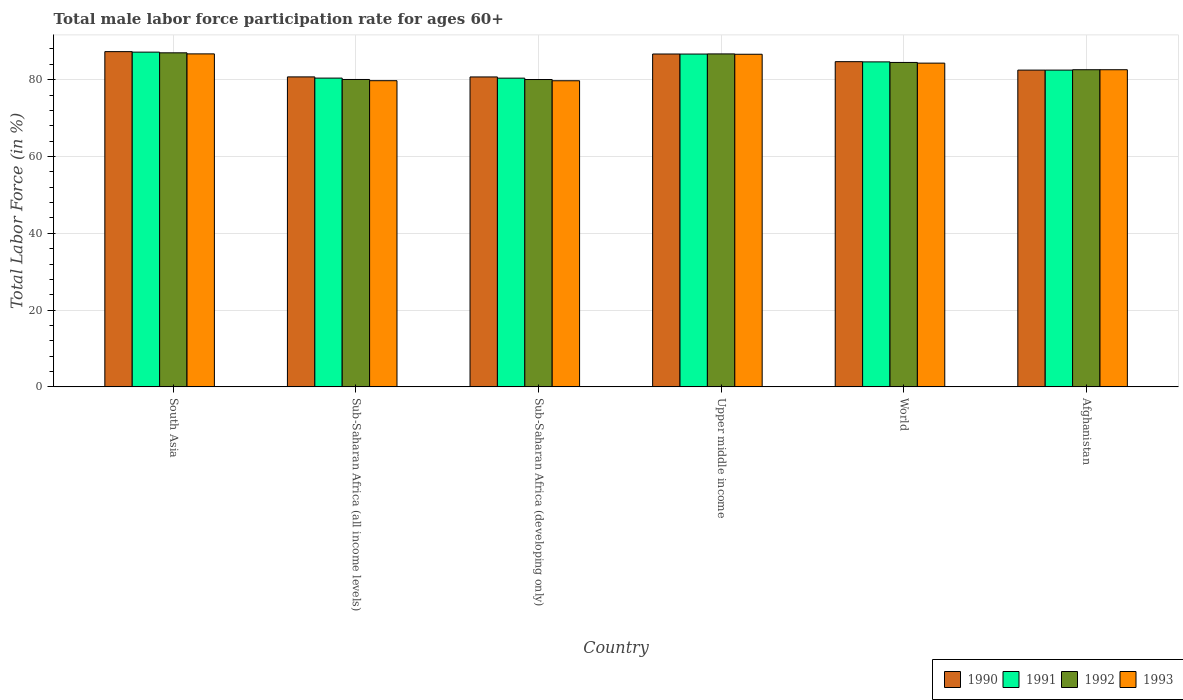How many groups of bars are there?
Your answer should be compact. 6. Are the number of bars per tick equal to the number of legend labels?
Offer a very short reply. Yes. How many bars are there on the 1st tick from the right?
Your answer should be very brief. 4. In how many cases, is the number of bars for a given country not equal to the number of legend labels?
Make the answer very short. 0. What is the male labor force participation rate in 1993 in Upper middle income?
Make the answer very short. 86.63. Across all countries, what is the maximum male labor force participation rate in 1991?
Your response must be concise. 87.18. Across all countries, what is the minimum male labor force participation rate in 1992?
Your answer should be very brief. 80.05. In which country was the male labor force participation rate in 1991 minimum?
Ensure brevity in your answer.  Sub-Saharan Africa (developing only). What is the total male labor force participation rate in 1993 in the graph?
Give a very brief answer. 499.74. What is the difference between the male labor force participation rate in 1993 in Sub-Saharan Africa (all income levels) and that in Upper middle income?
Offer a terse response. -6.89. What is the difference between the male labor force participation rate in 1992 in World and the male labor force participation rate in 1991 in Sub-Saharan Africa (all income levels)?
Keep it short and to the point. 4.08. What is the average male labor force participation rate in 1990 per country?
Your answer should be compact. 83.78. What is the difference between the male labor force participation rate of/in 1991 and male labor force participation rate of/in 1992 in World?
Give a very brief answer. 0.15. In how many countries, is the male labor force participation rate in 1991 greater than 8 %?
Ensure brevity in your answer.  6. What is the ratio of the male labor force participation rate in 1990 in Sub-Saharan Africa (all income levels) to that in Upper middle income?
Provide a succinct answer. 0.93. Is the male labor force participation rate in 1990 in Sub-Saharan Africa (developing only) less than that in Upper middle income?
Offer a terse response. Yes. Is the difference between the male labor force participation rate in 1991 in Upper middle income and World greater than the difference between the male labor force participation rate in 1992 in Upper middle income and World?
Keep it short and to the point. No. What is the difference between the highest and the second highest male labor force participation rate in 1993?
Your answer should be very brief. 2.31. What is the difference between the highest and the lowest male labor force participation rate in 1993?
Keep it short and to the point. 7. Is the sum of the male labor force participation rate in 1993 in Sub-Saharan Africa (all income levels) and Upper middle income greater than the maximum male labor force participation rate in 1990 across all countries?
Make the answer very short. Yes. What does the 2nd bar from the right in Afghanistan represents?
Offer a very short reply. 1992. Does the graph contain grids?
Provide a succinct answer. Yes. Where does the legend appear in the graph?
Provide a short and direct response. Bottom right. How are the legend labels stacked?
Offer a terse response. Horizontal. What is the title of the graph?
Provide a succinct answer. Total male labor force participation rate for ages 60+. What is the label or title of the X-axis?
Provide a succinct answer. Country. What is the label or title of the Y-axis?
Your answer should be very brief. Total Labor Force (in %). What is the Total Labor Force (in %) in 1990 in South Asia?
Provide a succinct answer. 87.31. What is the Total Labor Force (in %) in 1991 in South Asia?
Your answer should be very brief. 87.18. What is the Total Labor Force (in %) of 1992 in South Asia?
Offer a terse response. 87. What is the Total Labor Force (in %) of 1993 in South Asia?
Your response must be concise. 86.73. What is the Total Labor Force (in %) of 1990 in Sub-Saharan Africa (all income levels)?
Ensure brevity in your answer.  80.73. What is the Total Labor Force (in %) in 1991 in Sub-Saharan Africa (all income levels)?
Keep it short and to the point. 80.42. What is the Total Labor Force (in %) of 1992 in Sub-Saharan Africa (all income levels)?
Offer a terse response. 80.06. What is the Total Labor Force (in %) of 1993 in Sub-Saharan Africa (all income levels)?
Keep it short and to the point. 79.74. What is the Total Labor Force (in %) of 1990 in Sub-Saharan Africa (developing only)?
Ensure brevity in your answer.  80.72. What is the Total Labor Force (in %) of 1991 in Sub-Saharan Africa (developing only)?
Give a very brief answer. 80.41. What is the Total Labor Force (in %) of 1992 in Sub-Saharan Africa (developing only)?
Your answer should be compact. 80.05. What is the Total Labor Force (in %) in 1993 in Sub-Saharan Africa (developing only)?
Keep it short and to the point. 79.73. What is the Total Labor Force (in %) in 1990 in Upper middle income?
Provide a short and direct response. 86.69. What is the Total Labor Force (in %) in 1991 in Upper middle income?
Give a very brief answer. 86.68. What is the Total Labor Force (in %) in 1992 in Upper middle income?
Keep it short and to the point. 86.72. What is the Total Labor Force (in %) of 1993 in Upper middle income?
Your answer should be very brief. 86.63. What is the Total Labor Force (in %) of 1990 in World?
Your answer should be compact. 84.7. What is the Total Labor Force (in %) of 1991 in World?
Your answer should be very brief. 84.64. What is the Total Labor Force (in %) in 1992 in World?
Make the answer very short. 84.49. What is the Total Labor Force (in %) of 1993 in World?
Offer a terse response. 84.32. What is the Total Labor Force (in %) in 1990 in Afghanistan?
Keep it short and to the point. 82.5. What is the Total Labor Force (in %) in 1991 in Afghanistan?
Your response must be concise. 82.5. What is the Total Labor Force (in %) in 1992 in Afghanistan?
Your response must be concise. 82.6. What is the Total Labor Force (in %) in 1993 in Afghanistan?
Ensure brevity in your answer.  82.6. Across all countries, what is the maximum Total Labor Force (in %) in 1990?
Give a very brief answer. 87.31. Across all countries, what is the maximum Total Labor Force (in %) of 1991?
Your response must be concise. 87.18. Across all countries, what is the maximum Total Labor Force (in %) in 1992?
Make the answer very short. 87. Across all countries, what is the maximum Total Labor Force (in %) of 1993?
Offer a very short reply. 86.73. Across all countries, what is the minimum Total Labor Force (in %) in 1990?
Keep it short and to the point. 80.72. Across all countries, what is the minimum Total Labor Force (in %) in 1991?
Your response must be concise. 80.41. Across all countries, what is the minimum Total Labor Force (in %) of 1992?
Provide a short and direct response. 80.05. Across all countries, what is the minimum Total Labor Force (in %) in 1993?
Keep it short and to the point. 79.73. What is the total Total Labor Force (in %) of 1990 in the graph?
Your answer should be very brief. 502.65. What is the total Total Labor Force (in %) in 1991 in the graph?
Provide a succinct answer. 501.83. What is the total Total Labor Force (in %) in 1992 in the graph?
Your response must be concise. 500.92. What is the total Total Labor Force (in %) in 1993 in the graph?
Offer a terse response. 499.74. What is the difference between the Total Labor Force (in %) of 1990 in South Asia and that in Sub-Saharan Africa (all income levels)?
Your answer should be very brief. 6.58. What is the difference between the Total Labor Force (in %) in 1991 in South Asia and that in Sub-Saharan Africa (all income levels)?
Your answer should be compact. 6.76. What is the difference between the Total Labor Force (in %) in 1992 in South Asia and that in Sub-Saharan Africa (all income levels)?
Keep it short and to the point. 6.94. What is the difference between the Total Labor Force (in %) in 1993 in South Asia and that in Sub-Saharan Africa (all income levels)?
Ensure brevity in your answer.  6.99. What is the difference between the Total Labor Force (in %) in 1990 in South Asia and that in Sub-Saharan Africa (developing only)?
Ensure brevity in your answer.  6.59. What is the difference between the Total Labor Force (in %) of 1991 in South Asia and that in Sub-Saharan Africa (developing only)?
Give a very brief answer. 6.77. What is the difference between the Total Labor Force (in %) of 1992 in South Asia and that in Sub-Saharan Africa (developing only)?
Your answer should be very brief. 6.95. What is the difference between the Total Labor Force (in %) of 1993 in South Asia and that in Sub-Saharan Africa (developing only)?
Keep it short and to the point. 7. What is the difference between the Total Labor Force (in %) of 1990 in South Asia and that in Upper middle income?
Give a very brief answer. 0.62. What is the difference between the Total Labor Force (in %) of 1991 in South Asia and that in Upper middle income?
Offer a terse response. 0.5. What is the difference between the Total Labor Force (in %) in 1992 in South Asia and that in Upper middle income?
Make the answer very short. 0.28. What is the difference between the Total Labor Force (in %) of 1993 in South Asia and that in Upper middle income?
Provide a succinct answer. 0.1. What is the difference between the Total Labor Force (in %) in 1990 in South Asia and that in World?
Your answer should be very brief. 2.61. What is the difference between the Total Labor Force (in %) of 1991 in South Asia and that in World?
Provide a succinct answer. 2.54. What is the difference between the Total Labor Force (in %) of 1992 in South Asia and that in World?
Your answer should be compact. 2.51. What is the difference between the Total Labor Force (in %) of 1993 in South Asia and that in World?
Make the answer very short. 2.41. What is the difference between the Total Labor Force (in %) of 1990 in South Asia and that in Afghanistan?
Keep it short and to the point. 4.81. What is the difference between the Total Labor Force (in %) in 1991 in South Asia and that in Afghanistan?
Your answer should be compact. 4.68. What is the difference between the Total Labor Force (in %) in 1992 in South Asia and that in Afghanistan?
Make the answer very short. 4.4. What is the difference between the Total Labor Force (in %) in 1993 in South Asia and that in Afghanistan?
Your response must be concise. 4.13. What is the difference between the Total Labor Force (in %) of 1990 in Sub-Saharan Africa (all income levels) and that in Sub-Saharan Africa (developing only)?
Provide a succinct answer. 0.01. What is the difference between the Total Labor Force (in %) of 1991 in Sub-Saharan Africa (all income levels) and that in Sub-Saharan Africa (developing only)?
Your response must be concise. 0.01. What is the difference between the Total Labor Force (in %) of 1992 in Sub-Saharan Africa (all income levels) and that in Sub-Saharan Africa (developing only)?
Your response must be concise. 0.01. What is the difference between the Total Labor Force (in %) in 1993 in Sub-Saharan Africa (all income levels) and that in Sub-Saharan Africa (developing only)?
Make the answer very short. 0.01. What is the difference between the Total Labor Force (in %) in 1990 in Sub-Saharan Africa (all income levels) and that in Upper middle income?
Your response must be concise. -5.96. What is the difference between the Total Labor Force (in %) in 1991 in Sub-Saharan Africa (all income levels) and that in Upper middle income?
Give a very brief answer. -6.26. What is the difference between the Total Labor Force (in %) in 1992 in Sub-Saharan Africa (all income levels) and that in Upper middle income?
Give a very brief answer. -6.66. What is the difference between the Total Labor Force (in %) of 1993 in Sub-Saharan Africa (all income levels) and that in Upper middle income?
Ensure brevity in your answer.  -6.89. What is the difference between the Total Labor Force (in %) in 1990 in Sub-Saharan Africa (all income levels) and that in World?
Provide a succinct answer. -3.97. What is the difference between the Total Labor Force (in %) of 1991 in Sub-Saharan Africa (all income levels) and that in World?
Provide a succinct answer. -4.22. What is the difference between the Total Labor Force (in %) in 1992 in Sub-Saharan Africa (all income levels) and that in World?
Your answer should be compact. -4.43. What is the difference between the Total Labor Force (in %) of 1993 in Sub-Saharan Africa (all income levels) and that in World?
Offer a terse response. -4.57. What is the difference between the Total Labor Force (in %) in 1990 in Sub-Saharan Africa (all income levels) and that in Afghanistan?
Give a very brief answer. -1.77. What is the difference between the Total Labor Force (in %) of 1991 in Sub-Saharan Africa (all income levels) and that in Afghanistan?
Offer a terse response. -2.08. What is the difference between the Total Labor Force (in %) in 1992 in Sub-Saharan Africa (all income levels) and that in Afghanistan?
Your answer should be compact. -2.54. What is the difference between the Total Labor Force (in %) in 1993 in Sub-Saharan Africa (all income levels) and that in Afghanistan?
Provide a short and direct response. -2.86. What is the difference between the Total Labor Force (in %) in 1990 in Sub-Saharan Africa (developing only) and that in Upper middle income?
Ensure brevity in your answer.  -5.97. What is the difference between the Total Labor Force (in %) in 1991 in Sub-Saharan Africa (developing only) and that in Upper middle income?
Your response must be concise. -6.27. What is the difference between the Total Labor Force (in %) of 1992 in Sub-Saharan Africa (developing only) and that in Upper middle income?
Your answer should be very brief. -6.67. What is the difference between the Total Labor Force (in %) of 1990 in Sub-Saharan Africa (developing only) and that in World?
Offer a very short reply. -3.98. What is the difference between the Total Labor Force (in %) in 1991 in Sub-Saharan Africa (developing only) and that in World?
Make the answer very short. -4.24. What is the difference between the Total Labor Force (in %) in 1992 in Sub-Saharan Africa (developing only) and that in World?
Make the answer very short. -4.45. What is the difference between the Total Labor Force (in %) in 1993 in Sub-Saharan Africa (developing only) and that in World?
Offer a terse response. -4.59. What is the difference between the Total Labor Force (in %) in 1990 in Sub-Saharan Africa (developing only) and that in Afghanistan?
Offer a very short reply. -1.78. What is the difference between the Total Labor Force (in %) of 1991 in Sub-Saharan Africa (developing only) and that in Afghanistan?
Provide a short and direct response. -2.09. What is the difference between the Total Labor Force (in %) of 1992 in Sub-Saharan Africa (developing only) and that in Afghanistan?
Provide a succinct answer. -2.55. What is the difference between the Total Labor Force (in %) in 1993 in Sub-Saharan Africa (developing only) and that in Afghanistan?
Your response must be concise. -2.87. What is the difference between the Total Labor Force (in %) in 1990 in Upper middle income and that in World?
Ensure brevity in your answer.  1.99. What is the difference between the Total Labor Force (in %) of 1991 in Upper middle income and that in World?
Your answer should be very brief. 2.04. What is the difference between the Total Labor Force (in %) of 1992 in Upper middle income and that in World?
Offer a very short reply. 2.22. What is the difference between the Total Labor Force (in %) of 1993 in Upper middle income and that in World?
Offer a terse response. 2.31. What is the difference between the Total Labor Force (in %) of 1990 in Upper middle income and that in Afghanistan?
Keep it short and to the point. 4.19. What is the difference between the Total Labor Force (in %) in 1991 in Upper middle income and that in Afghanistan?
Offer a very short reply. 4.18. What is the difference between the Total Labor Force (in %) in 1992 in Upper middle income and that in Afghanistan?
Offer a very short reply. 4.12. What is the difference between the Total Labor Force (in %) in 1993 in Upper middle income and that in Afghanistan?
Offer a very short reply. 4.03. What is the difference between the Total Labor Force (in %) of 1990 in World and that in Afghanistan?
Provide a succinct answer. 2.2. What is the difference between the Total Labor Force (in %) in 1991 in World and that in Afghanistan?
Your answer should be compact. 2.14. What is the difference between the Total Labor Force (in %) of 1992 in World and that in Afghanistan?
Make the answer very short. 1.89. What is the difference between the Total Labor Force (in %) in 1993 in World and that in Afghanistan?
Your answer should be very brief. 1.72. What is the difference between the Total Labor Force (in %) in 1990 in South Asia and the Total Labor Force (in %) in 1991 in Sub-Saharan Africa (all income levels)?
Keep it short and to the point. 6.89. What is the difference between the Total Labor Force (in %) in 1990 in South Asia and the Total Labor Force (in %) in 1992 in Sub-Saharan Africa (all income levels)?
Your answer should be compact. 7.25. What is the difference between the Total Labor Force (in %) of 1990 in South Asia and the Total Labor Force (in %) of 1993 in Sub-Saharan Africa (all income levels)?
Make the answer very short. 7.57. What is the difference between the Total Labor Force (in %) in 1991 in South Asia and the Total Labor Force (in %) in 1992 in Sub-Saharan Africa (all income levels)?
Keep it short and to the point. 7.12. What is the difference between the Total Labor Force (in %) in 1991 in South Asia and the Total Labor Force (in %) in 1993 in Sub-Saharan Africa (all income levels)?
Provide a succinct answer. 7.44. What is the difference between the Total Labor Force (in %) in 1992 in South Asia and the Total Labor Force (in %) in 1993 in Sub-Saharan Africa (all income levels)?
Ensure brevity in your answer.  7.26. What is the difference between the Total Labor Force (in %) of 1990 in South Asia and the Total Labor Force (in %) of 1991 in Sub-Saharan Africa (developing only)?
Give a very brief answer. 6.9. What is the difference between the Total Labor Force (in %) in 1990 in South Asia and the Total Labor Force (in %) in 1992 in Sub-Saharan Africa (developing only)?
Ensure brevity in your answer.  7.26. What is the difference between the Total Labor Force (in %) in 1990 in South Asia and the Total Labor Force (in %) in 1993 in Sub-Saharan Africa (developing only)?
Provide a short and direct response. 7.58. What is the difference between the Total Labor Force (in %) in 1991 in South Asia and the Total Labor Force (in %) in 1992 in Sub-Saharan Africa (developing only)?
Provide a succinct answer. 7.13. What is the difference between the Total Labor Force (in %) in 1991 in South Asia and the Total Labor Force (in %) in 1993 in Sub-Saharan Africa (developing only)?
Make the answer very short. 7.45. What is the difference between the Total Labor Force (in %) in 1992 in South Asia and the Total Labor Force (in %) in 1993 in Sub-Saharan Africa (developing only)?
Your answer should be compact. 7.27. What is the difference between the Total Labor Force (in %) of 1990 in South Asia and the Total Labor Force (in %) of 1991 in Upper middle income?
Your answer should be very brief. 0.63. What is the difference between the Total Labor Force (in %) of 1990 in South Asia and the Total Labor Force (in %) of 1992 in Upper middle income?
Offer a terse response. 0.59. What is the difference between the Total Labor Force (in %) of 1990 in South Asia and the Total Labor Force (in %) of 1993 in Upper middle income?
Provide a short and direct response. 0.68. What is the difference between the Total Labor Force (in %) of 1991 in South Asia and the Total Labor Force (in %) of 1992 in Upper middle income?
Your response must be concise. 0.46. What is the difference between the Total Labor Force (in %) in 1991 in South Asia and the Total Labor Force (in %) in 1993 in Upper middle income?
Offer a very short reply. 0.55. What is the difference between the Total Labor Force (in %) in 1992 in South Asia and the Total Labor Force (in %) in 1993 in Upper middle income?
Provide a succinct answer. 0.37. What is the difference between the Total Labor Force (in %) of 1990 in South Asia and the Total Labor Force (in %) of 1991 in World?
Make the answer very short. 2.67. What is the difference between the Total Labor Force (in %) of 1990 in South Asia and the Total Labor Force (in %) of 1992 in World?
Your response must be concise. 2.82. What is the difference between the Total Labor Force (in %) in 1990 in South Asia and the Total Labor Force (in %) in 1993 in World?
Your answer should be compact. 3. What is the difference between the Total Labor Force (in %) in 1991 in South Asia and the Total Labor Force (in %) in 1992 in World?
Provide a short and direct response. 2.69. What is the difference between the Total Labor Force (in %) in 1991 in South Asia and the Total Labor Force (in %) in 1993 in World?
Keep it short and to the point. 2.87. What is the difference between the Total Labor Force (in %) of 1992 in South Asia and the Total Labor Force (in %) of 1993 in World?
Ensure brevity in your answer.  2.69. What is the difference between the Total Labor Force (in %) in 1990 in South Asia and the Total Labor Force (in %) in 1991 in Afghanistan?
Offer a very short reply. 4.81. What is the difference between the Total Labor Force (in %) in 1990 in South Asia and the Total Labor Force (in %) in 1992 in Afghanistan?
Provide a succinct answer. 4.71. What is the difference between the Total Labor Force (in %) in 1990 in South Asia and the Total Labor Force (in %) in 1993 in Afghanistan?
Give a very brief answer. 4.71. What is the difference between the Total Labor Force (in %) in 1991 in South Asia and the Total Labor Force (in %) in 1992 in Afghanistan?
Make the answer very short. 4.58. What is the difference between the Total Labor Force (in %) of 1991 in South Asia and the Total Labor Force (in %) of 1993 in Afghanistan?
Your response must be concise. 4.58. What is the difference between the Total Labor Force (in %) of 1992 in South Asia and the Total Labor Force (in %) of 1993 in Afghanistan?
Ensure brevity in your answer.  4.4. What is the difference between the Total Labor Force (in %) of 1990 in Sub-Saharan Africa (all income levels) and the Total Labor Force (in %) of 1991 in Sub-Saharan Africa (developing only)?
Provide a succinct answer. 0.33. What is the difference between the Total Labor Force (in %) in 1990 in Sub-Saharan Africa (all income levels) and the Total Labor Force (in %) in 1992 in Sub-Saharan Africa (developing only)?
Your answer should be very brief. 0.68. What is the difference between the Total Labor Force (in %) of 1991 in Sub-Saharan Africa (all income levels) and the Total Labor Force (in %) of 1992 in Sub-Saharan Africa (developing only)?
Offer a terse response. 0.37. What is the difference between the Total Labor Force (in %) in 1991 in Sub-Saharan Africa (all income levels) and the Total Labor Force (in %) in 1993 in Sub-Saharan Africa (developing only)?
Offer a terse response. 0.69. What is the difference between the Total Labor Force (in %) of 1992 in Sub-Saharan Africa (all income levels) and the Total Labor Force (in %) of 1993 in Sub-Saharan Africa (developing only)?
Your answer should be very brief. 0.33. What is the difference between the Total Labor Force (in %) in 1990 in Sub-Saharan Africa (all income levels) and the Total Labor Force (in %) in 1991 in Upper middle income?
Provide a short and direct response. -5.95. What is the difference between the Total Labor Force (in %) of 1990 in Sub-Saharan Africa (all income levels) and the Total Labor Force (in %) of 1992 in Upper middle income?
Provide a short and direct response. -5.99. What is the difference between the Total Labor Force (in %) in 1990 in Sub-Saharan Africa (all income levels) and the Total Labor Force (in %) in 1993 in Upper middle income?
Provide a short and direct response. -5.9. What is the difference between the Total Labor Force (in %) of 1991 in Sub-Saharan Africa (all income levels) and the Total Labor Force (in %) of 1992 in Upper middle income?
Keep it short and to the point. -6.3. What is the difference between the Total Labor Force (in %) in 1991 in Sub-Saharan Africa (all income levels) and the Total Labor Force (in %) in 1993 in Upper middle income?
Your response must be concise. -6.21. What is the difference between the Total Labor Force (in %) of 1992 in Sub-Saharan Africa (all income levels) and the Total Labor Force (in %) of 1993 in Upper middle income?
Your answer should be compact. -6.57. What is the difference between the Total Labor Force (in %) of 1990 in Sub-Saharan Africa (all income levels) and the Total Labor Force (in %) of 1991 in World?
Offer a terse response. -3.91. What is the difference between the Total Labor Force (in %) in 1990 in Sub-Saharan Africa (all income levels) and the Total Labor Force (in %) in 1992 in World?
Provide a succinct answer. -3.76. What is the difference between the Total Labor Force (in %) of 1990 in Sub-Saharan Africa (all income levels) and the Total Labor Force (in %) of 1993 in World?
Keep it short and to the point. -3.58. What is the difference between the Total Labor Force (in %) of 1991 in Sub-Saharan Africa (all income levels) and the Total Labor Force (in %) of 1992 in World?
Offer a very short reply. -4.08. What is the difference between the Total Labor Force (in %) in 1991 in Sub-Saharan Africa (all income levels) and the Total Labor Force (in %) in 1993 in World?
Ensure brevity in your answer.  -3.9. What is the difference between the Total Labor Force (in %) of 1992 in Sub-Saharan Africa (all income levels) and the Total Labor Force (in %) of 1993 in World?
Keep it short and to the point. -4.25. What is the difference between the Total Labor Force (in %) of 1990 in Sub-Saharan Africa (all income levels) and the Total Labor Force (in %) of 1991 in Afghanistan?
Your answer should be very brief. -1.77. What is the difference between the Total Labor Force (in %) of 1990 in Sub-Saharan Africa (all income levels) and the Total Labor Force (in %) of 1992 in Afghanistan?
Your response must be concise. -1.87. What is the difference between the Total Labor Force (in %) in 1990 in Sub-Saharan Africa (all income levels) and the Total Labor Force (in %) in 1993 in Afghanistan?
Your answer should be compact. -1.87. What is the difference between the Total Labor Force (in %) of 1991 in Sub-Saharan Africa (all income levels) and the Total Labor Force (in %) of 1992 in Afghanistan?
Your response must be concise. -2.18. What is the difference between the Total Labor Force (in %) in 1991 in Sub-Saharan Africa (all income levels) and the Total Labor Force (in %) in 1993 in Afghanistan?
Offer a very short reply. -2.18. What is the difference between the Total Labor Force (in %) of 1992 in Sub-Saharan Africa (all income levels) and the Total Labor Force (in %) of 1993 in Afghanistan?
Keep it short and to the point. -2.54. What is the difference between the Total Labor Force (in %) of 1990 in Sub-Saharan Africa (developing only) and the Total Labor Force (in %) of 1991 in Upper middle income?
Your response must be concise. -5.96. What is the difference between the Total Labor Force (in %) of 1990 in Sub-Saharan Africa (developing only) and the Total Labor Force (in %) of 1992 in Upper middle income?
Provide a short and direct response. -6. What is the difference between the Total Labor Force (in %) in 1990 in Sub-Saharan Africa (developing only) and the Total Labor Force (in %) in 1993 in Upper middle income?
Your answer should be very brief. -5.91. What is the difference between the Total Labor Force (in %) in 1991 in Sub-Saharan Africa (developing only) and the Total Labor Force (in %) in 1992 in Upper middle income?
Give a very brief answer. -6.31. What is the difference between the Total Labor Force (in %) in 1991 in Sub-Saharan Africa (developing only) and the Total Labor Force (in %) in 1993 in Upper middle income?
Give a very brief answer. -6.22. What is the difference between the Total Labor Force (in %) of 1992 in Sub-Saharan Africa (developing only) and the Total Labor Force (in %) of 1993 in Upper middle income?
Keep it short and to the point. -6.58. What is the difference between the Total Labor Force (in %) in 1990 in Sub-Saharan Africa (developing only) and the Total Labor Force (in %) in 1991 in World?
Make the answer very short. -3.92. What is the difference between the Total Labor Force (in %) of 1990 in Sub-Saharan Africa (developing only) and the Total Labor Force (in %) of 1992 in World?
Offer a terse response. -3.77. What is the difference between the Total Labor Force (in %) of 1990 in Sub-Saharan Africa (developing only) and the Total Labor Force (in %) of 1993 in World?
Your answer should be very brief. -3.59. What is the difference between the Total Labor Force (in %) of 1991 in Sub-Saharan Africa (developing only) and the Total Labor Force (in %) of 1992 in World?
Ensure brevity in your answer.  -4.09. What is the difference between the Total Labor Force (in %) of 1991 in Sub-Saharan Africa (developing only) and the Total Labor Force (in %) of 1993 in World?
Your answer should be compact. -3.91. What is the difference between the Total Labor Force (in %) in 1992 in Sub-Saharan Africa (developing only) and the Total Labor Force (in %) in 1993 in World?
Give a very brief answer. -4.27. What is the difference between the Total Labor Force (in %) of 1990 in Sub-Saharan Africa (developing only) and the Total Labor Force (in %) of 1991 in Afghanistan?
Offer a very short reply. -1.78. What is the difference between the Total Labor Force (in %) in 1990 in Sub-Saharan Africa (developing only) and the Total Labor Force (in %) in 1992 in Afghanistan?
Make the answer very short. -1.88. What is the difference between the Total Labor Force (in %) in 1990 in Sub-Saharan Africa (developing only) and the Total Labor Force (in %) in 1993 in Afghanistan?
Keep it short and to the point. -1.88. What is the difference between the Total Labor Force (in %) of 1991 in Sub-Saharan Africa (developing only) and the Total Labor Force (in %) of 1992 in Afghanistan?
Offer a terse response. -2.19. What is the difference between the Total Labor Force (in %) in 1991 in Sub-Saharan Africa (developing only) and the Total Labor Force (in %) in 1993 in Afghanistan?
Make the answer very short. -2.19. What is the difference between the Total Labor Force (in %) in 1992 in Sub-Saharan Africa (developing only) and the Total Labor Force (in %) in 1993 in Afghanistan?
Provide a succinct answer. -2.55. What is the difference between the Total Labor Force (in %) of 1990 in Upper middle income and the Total Labor Force (in %) of 1991 in World?
Your answer should be very brief. 2.05. What is the difference between the Total Labor Force (in %) in 1990 in Upper middle income and the Total Labor Force (in %) in 1992 in World?
Provide a succinct answer. 2.2. What is the difference between the Total Labor Force (in %) of 1990 in Upper middle income and the Total Labor Force (in %) of 1993 in World?
Your answer should be compact. 2.38. What is the difference between the Total Labor Force (in %) of 1991 in Upper middle income and the Total Labor Force (in %) of 1992 in World?
Offer a terse response. 2.19. What is the difference between the Total Labor Force (in %) in 1991 in Upper middle income and the Total Labor Force (in %) in 1993 in World?
Provide a short and direct response. 2.37. What is the difference between the Total Labor Force (in %) in 1992 in Upper middle income and the Total Labor Force (in %) in 1993 in World?
Your answer should be very brief. 2.4. What is the difference between the Total Labor Force (in %) of 1990 in Upper middle income and the Total Labor Force (in %) of 1991 in Afghanistan?
Give a very brief answer. 4.19. What is the difference between the Total Labor Force (in %) in 1990 in Upper middle income and the Total Labor Force (in %) in 1992 in Afghanistan?
Offer a very short reply. 4.09. What is the difference between the Total Labor Force (in %) in 1990 in Upper middle income and the Total Labor Force (in %) in 1993 in Afghanistan?
Keep it short and to the point. 4.09. What is the difference between the Total Labor Force (in %) in 1991 in Upper middle income and the Total Labor Force (in %) in 1992 in Afghanistan?
Offer a very short reply. 4.08. What is the difference between the Total Labor Force (in %) of 1991 in Upper middle income and the Total Labor Force (in %) of 1993 in Afghanistan?
Your response must be concise. 4.08. What is the difference between the Total Labor Force (in %) in 1992 in Upper middle income and the Total Labor Force (in %) in 1993 in Afghanistan?
Give a very brief answer. 4.12. What is the difference between the Total Labor Force (in %) in 1990 in World and the Total Labor Force (in %) in 1991 in Afghanistan?
Make the answer very short. 2.2. What is the difference between the Total Labor Force (in %) in 1990 in World and the Total Labor Force (in %) in 1992 in Afghanistan?
Provide a succinct answer. 2.1. What is the difference between the Total Labor Force (in %) in 1990 in World and the Total Labor Force (in %) in 1993 in Afghanistan?
Provide a succinct answer. 2.1. What is the difference between the Total Labor Force (in %) in 1991 in World and the Total Labor Force (in %) in 1992 in Afghanistan?
Make the answer very short. 2.04. What is the difference between the Total Labor Force (in %) of 1991 in World and the Total Labor Force (in %) of 1993 in Afghanistan?
Give a very brief answer. 2.04. What is the difference between the Total Labor Force (in %) in 1992 in World and the Total Labor Force (in %) in 1993 in Afghanistan?
Your answer should be compact. 1.89. What is the average Total Labor Force (in %) in 1990 per country?
Ensure brevity in your answer.  83.78. What is the average Total Labor Force (in %) in 1991 per country?
Your answer should be very brief. 83.64. What is the average Total Labor Force (in %) in 1992 per country?
Your response must be concise. 83.49. What is the average Total Labor Force (in %) of 1993 per country?
Keep it short and to the point. 83.29. What is the difference between the Total Labor Force (in %) in 1990 and Total Labor Force (in %) in 1991 in South Asia?
Provide a succinct answer. 0.13. What is the difference between the Total Labor Force (in %) in 1990 and Total Labor Force (in %) in 1992 in South Asia?
Keep it short and to the point. 0.31. What is the difference between the Total Labor Force (in %) in 1990 and Total Labor Force (in %) in 1993 in South Asia?
Your response must be concise. 0.58. What is the difference between the Total Labor Force (in %) in 1991 and Total Labor Force (in %) in 1992 in South Asia?
Ensure brevity in your answer.  0.18. What is the difference between the Total Labor Force (in %) of 1991 and Total Labor Force (in %) of 1993 in South Asia?
Offer a very short reply. 0.45. What is the difference between the Total Labor Force (in %) of 1992 and Total Labor Force (in %) of 1993 in South Asia?
Ensure brevity in your answer.  0.27. What is the difference between the Total Labor Force (in %) in 1990 and Total Labor Force (in %) in 1991 in Sub-Saharan Africa (all income levels)?
Keep it short and to the point. 0.31. What is the difference between the Total Labor Force (in %) of 1990 and Total Labor Force (in %) of 1992 in Sub-Saharan Africa (all income levels)?
Provide a short and direct response. 0.67. What is the difference between the Total Labor Force (in %) in 1990 and Total Labor Force (in %) in 1993 in Sub-Saharan Africa (all income levels)?
Your response must be concise. 0.99. What is the difference between the Total Labor Force (in %) in 1991 and Total Labor Force (in %) in 1992 in Sub-Saharan Africa (all income levels)?
Your answer should be very brief. 0.36. What is the difference between the Total Labor Force (in %) of 1991 and Total Labor Force (in %) of 1993 in Sub-Saharan Africa (all income levels)?
Ensure brevity in your answer.  0.68. What is the difference between the Total Labor Force (in %) of 1992 and Total Labor Force (in %) of 1993 in Sub-Saharan Africa (all income levels)?
Offer a terse response. 0.32. What is the difference between the Total Labor Force (in %) of 1990 and Total Labor Force (in %) of 1991 in Sub-Saharan Africa (developing only)?
Your response must be concise. 0.31. What is the difference between the Total Labor Force (in %) of 1990 and Total Labor Force (in %) of 1992 in Sub-Saharan Africa (developing only)?
Offer a terse response. 0.67. What is the difference between the Total Labor Force (in %) in 1990 and Total Labor Force (in %) in 1993 in Sub-Saharan Africa (developing only)?
Offer a very short reply. 0.99. What is the difference between the Total Labor Force (in %) in 1991 and Total Labor Force (in %) in 1992 in Sub-Saharan Africa (developing only)?
Offer a very short reply. 0.36. What is the difference between the Total Labor Force (in %) of 1991 and Total Labor Force (in %) of 1993 in Sub-Saharan Africa (developing only)?
Your answer should be very brief. 0.68. What is the difference between the Total Labor Force (in %) of 1992 and Total Labor Force (in %) of 1993 in Sub-Saharan Africa (developing only)?
Your response must be concise. 0.32. What is the difference between the Total Labor Force (in %) in 1990 and Total Labor Force (in %) in 1991 in Upper middle income?
Provide a short and direct response. 0.01. What is the difference between the Total Labor Force (in %) in 1990 and Total Labor Force (in %) in 1992 in Upper middle income?
Offer a terse response. -0.03. What is the difference between the Total Labor Force (in %) of 1990 and Total Labor Force (in %) of 1993 in Upper middle income?
Your answer should be very brief. 0.07. What is the difference between the Total Labor Force (in %) in 1991 and Total Labor Force (in %) in 1992 in Upper middle income?
Your answer should be very brief. -0.04. What is the difference between the Total Labor Force (in %) in 1991 and Total Labor Force (in %) in 1993 in Upper middle income?
Offer a very short reply. 0.05. What is the difference between the Total Labor Force (in %) in 1992 and Total Labor Force (in %) in 1993 in Upper middle income?
Keep it short and to the point. 0.09. What is the difference between the Total Labor Force (in %) of 1990 and Total Labor Force (in %) of 1991 in World?
Your answer should be compact. 0.06. What is the difference between the Total Labor Force (in %) of 1990 and Total Labor Force (in %) of 1992 in World?
Ensure brevity in your answer.  0.2. What is the difference between the Total Labor Force (in %) in 1990 and Total Labor Force (in %) in 1993 in World?
Provide a short and direct response. 0.38. What is the difference between the Total Labor Force (in %) in 1991 and Total Labor Force (in %) in 1992 in World?
Your response must be concise. 0.15. What is the difference between the Total Labor Force (in %) in 1991 and Total Labor Force (in %) in 1993 in World?
Provide a succinct answer. 0.33. What is the difference between the Total Labor Force (in %) of 1992 and Total Labor Force (in %) of 1993 in World?
Your response must be concise. 0.18. What is the difference between the Total Labor Force (in %) of 1990 and Total Labor Force (in %) of 1991 in Afghanistan?
Give a very brief answer. 0. What is the difference between the Total Labor Force (in %) in 1990 and Total Labor Force (in %) in 1992 in Afghanistan?
Keep it short and to the point. -0.1. What is the ratio of the Total Labor Force (in %) of 1990 in South Asia to that in Sub-Saharan Africa (all income levels)?
Provide a succinct answer. 1.08. What is the ratio of the Total Labor Force (in %) in 1991 in South Asia to that in Sub-Saharan Africa (all income levels)?
Your answer should be compact. 1.08. What is the ratio of the Total Labor Force (in %) of 1992 in South Asia to that in Sub-Saharan Africa (all income levels)?
Make the answer very short. 1.09. What is the ratio of the Total Labor Force (in %) in 1993 in South Asia to that in Sub-Saharan Africa (all income levels)?
Your answer should be very brief. 1.09. What is the ratio of the Total Labor Force (in %) of 1990 in South Asia to that in Sub-Saharan Africa (developing only)?
Your answer should be very brief. 1.08. What is the ratio of the Total Labor Force (in %) of 1991 in South Asia to that in Sub-Saharan Africa (developing only)?
Keep it short and to the point. 1.08. What is the ratio of the Total Labor Force (in %) in 1992 in South Asia to that in Sub-Saharan Africa (developing only)?
Offer a terse response. 1.09. What is the ratio of the Total Labor Force (in %) of 1993 in South Asia to that in Sub-Saharan Africa (developing only)?
Provide a succinct answer. 1.09. What is the ratio of the Total Labor Force (in %) in 1990 in South Asia to that in Upper middle income?
Ensure brevity in your answer.  1.01. What is the ratio of the Total Labor Force (in %) of 1991 in South Asia to that in Upper middle income?
Your response must be concise. 1.01. What is the ratio of the Total Labor Force (in %) of 1992 in South Asia to that in Upper middle income?
Your answer should be compact. 1. What is the ratio of the Total Labor Force (in %) in 1993 in South Asia to that in Upper middle income?
Your answer should be compact. 1. What is the ratio of the Total Labor Force (in %) of 1990 in South Asia to that in World?
Give a very brief answer. 1.03. What is the ratio of the Total Labor Force (in %) of 1992 in South Asia to that in World?
Your answer should be very brief. 1.03. What is the ratio of the Total Labor Force (in %) in 1993 in South Asia to that in World?
Your answer should be compact. 1.03. What is the ratio of the Total Labor Force (in %) in 1990 in South Asia to that in Afghanistan?
Your answer should be compact. 1.06. What is the ratio of the Total Labor Force (in %) of 1991 in South Asia to that in Afghanistan?
Offer a terse response. 1.06. What is the ratio of the Total Labor Force (in %) of 1992 in South Asia to that in Afghanistan?
Give a very brief answer. 1.05. What is the ratio of the Total Labor Force (in %) of 1993 in South Asia to that in Afghanistan?
Keep it short and to the point. 1.05. What is the ratio of the Total Labor Force (in %) of 1993 in Sub-Saharan Africa (all income levels) to that in Sub-Saharan Africa (developing only)?
Make the answer very short. 1. What is the ratio of the Total Labor Force (in %) in 1990 in Sub-Saharan Africa (all income levels) to that in Upper middle income?
Provide a succinct answer. 0.93. What is the ratio of the Total Labor Force (in %) in 1991 in Sub-Saharan Africa (all income levels) to that in Upper middle income?
Offer a very short reply. 0.93. What is the ratio of the Total Labor Force (in %) of 1992 in Sub-Saharan Africa (all income levels) to that in Upper middle income?
Give a very brief answer. 0.92. What is the ratio of the Total Labor Force (in %) of 1993 in Sub-Saharan Africa (all income levels) to that in Upper middle income?
Offer a terse response. 0.92. What is the ratio of the Total Labor Force (in %) of 1990 in Sub-Saharan Africa (all income levels) to that in World?
Your answer should be compact. 0.95. What is the ratio of the Total Labor Force (in %) of 1991 in Sub-Saharan Africa (all income levels) to that in World?
Your answer should be compact. 0.95. What is the ratio of the Total Labor Force (in %) in 1992 in Sub-Saharan Africa (all income levels) to that in World?
Your answer should be very brief. 0.95. What is the ratio of the Total Labor Force (in %) in 1993 in Sub-Saharan Africa (all income levels) to that in World?
Give a very brief answer. 0.95. What is the ratio of the Total Labor Force (in %) of 1990 in Sub-Saharan Africa (all income levels) to that in Afghanistan?
Your answer should be compact. 0.98. What is the ratio of the Total Labor Force (in %) of 1991 in Sub-Saharan Africa (all income levels) to that in Afghanistan?
Your answer should be compact. 0.97. What is the ratio of the Total Labor Force (in %) of 1992 in Sub-Saharan Africa (all income levels) to that in Afghanistan?
Provide a short and direct response. 0.97. What is the ratio of the Total Labor Force (in %) of 1993 in Sub-Saharan Africa (all income levels) to that in Afghanistan?
Your response must be concise. 0.97. What is the ratio of the Total Labor Force (in %) of 1990 in Sub-Saharan Africa (developing only) to that in Upper middle income?
Provide a short and direct response. 0.93. What is the ratio of the Total Labor Force (in %) in 1991 in Sub-Saharan Africa (developing only) to that in Upper middle income?
Give a very brief answer. 0.93. What is the ratio of the Total Labor Force (in %) of 1992 in Sub-Saharan Africa (developing only) to that in Upper middle income?
Provide a short and direct response. 0.92. What is the ratio of the Total Labor Force (in %) of 1993 in Sub-Saharan Africa (developing only) to that in Upper middle income?
Keep it short and to the point. 0.92. What is the ratio of the Total Labor Force (in %) of 1990 in Sub-Saharan Africa (developing only) to that in World?
Ensure brevity in your answer.  0.95. What is the ratio of the Total Labor Force (in %) of 1992 in Sub-Saharan Africa (developing only) to that in World?
Provide a short and direct response. 0.95. What is the ratio of the Total Labor Force (in %) in 1993 in Sub-Saharan Africa (developing only) to that in World?
Offer a very short reply. 0.95. What is the ratio of the Total Labor Force (in %) of 1990 in Sub-Saharan Africa (developing only) to that in Afghanistan?
Your answer should be compact. 0.98. What is the ratio of the Total Labor Force (in %) of 1991 in Sub-Saharan Africa (developing only) to that in Afghanistan?
Offer a terse response. 0.97. What is the ratio of the Total Labor Force (in %) of 1992 in Sub-Saharan Africa (developing only) to that in Afghanistan?
Keep it short and to the point. 0.97. What is the ratio of the Total Labor Force (in %) in 1993 in Sub-Saharan Africa (developing only) to that in Afghanistan?
Provide a succinct answer. 0.97. What is the ratio of the Total Labor Force (in %) in 1990 in Upper middle income to that in World?
Give a very brief answer. 1.02. What is the ratio of the Total Labor Force (in %) of 1991 in Upper middle income to that in World?
Keep it short and to the point. 1.02. What is the ratio of the Total Labor Force (in %) in 1992 in Upper middle income to that in World?
Your answer should be very brief. 1.03. What is the ratio of the Total Labor Force (in %) of 1993 in Upper middle income to that in World?
Your response must be concise. 1.03. What is the ratio of the Total Labor Force (in %) in 1990 in Upper middle income to that in Afghanistan?
Offer a very short reply. 1.05. What is the ratio of the Total Labor Force (in %) in 1991 in Upper middle income to that in Afghanistan?
Ensure brevity in your answer.  1.05. What is the ratio of the Total Labor Force (in %) in 1992 in Upper middle income to that in Afghanistan?
Your response must be concise. 1.05. What is the ratio of the Total Labor Force (in %) in 1993 in Upper middle income to that in Afghanistan?
Provide a succinct answer. 1.05. What is the ratio of the Total Labor Force (in %) of 1990 in World to that in Afghanistan?
Offer a very short reply. 1.03. What is the ratio of the Total Labor Force (in %) in 1992 in World to that in Afghanistan?
Provide a succinct answer. 1.02. What is the ratio of the Total Labor Force (in %) of 1993 in World to that in Afghanistan?
Your response must be concise. 1.02. What is the difference between the highest and the second highest Total Labor Force (in %) in 1990?
Provide a succinct answer. 0.62. What is the difference between the highest and the second highest Total Labor Force (in %) in 1991?
Give a very brief answer. 0.5. What is the difference between the highest and the second highest Total Labor Force (in %) in 1992?
Your answer should be compact. 0.28. What is the difference between the highest and the second highest Total Labor Force (in %) of 1993?
Keep it short and to the point. 0.1. What is the difference between the highest and the lowest Total Labor Force (in %) in 1990?
Your response must be concise. 6.59. What is the difference between the highest and the lowest Total Labor Force (in %) in 1991?
Offer a very short reply. 6.77. What is the difference between the highest and the lowest Total Labor Force (in %) in 1992?
Offer a very short reply. 6.95. What is the difference between the highest and the lowest Total Labor Force (in %) of 1993?
Keep it short and to the point. 7. 